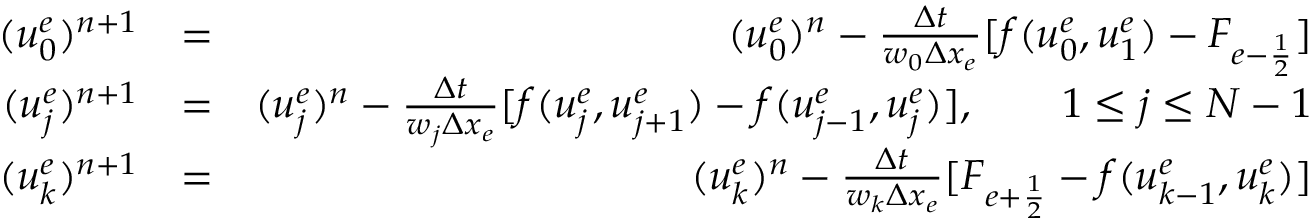<formula> <loc_0><loc_0><loc_500><loc_500>\begin{array} { r l r } { ( u _ { 0 } ^ { e } ) ^ { n + 1 } } & { = } & { ( u _ { 0 } ^ { e } ) ^ { n } - \frac { \Delta t } { w _ { 0 } \Delta x _ { e } } [ f ( u _ { 0 } ^ { e } , u _ { 1 } ^ { e } ) - F _ { e - \frac { 1 } { 2 } } ] } \\ { ( u _ { j } ^ { e } ) ^ { n + 1 } } & { = } & { ( u _ { j } ^ { e } ) ^ { n } - \frac { \Delta t } { w _ { j } \Delta x _ { e } } [ f ( u _ { j } ^ { e } , u _ { j + 1 } ^ { e } ) - f ( u _ { j - 1 } ^ { e } , u _ { j } ^ { e } ) ] , \quad 1 \leq j \leq N - 1 } \\ { ( u _ { k } ^ { e } ) ^ { n + 1 } } & { = } & { ( u _ { k } ^ { e } ) ^ { n } - \frac { \Delta t } { w _ { k } \Delta x _ { e } } [ F _ { e + \frac { 1 } { 2 } } - f ( u _ { k - 1 } ^ { e } , u _ { k } ^ { e } ) ] } \end{array}</formula> 